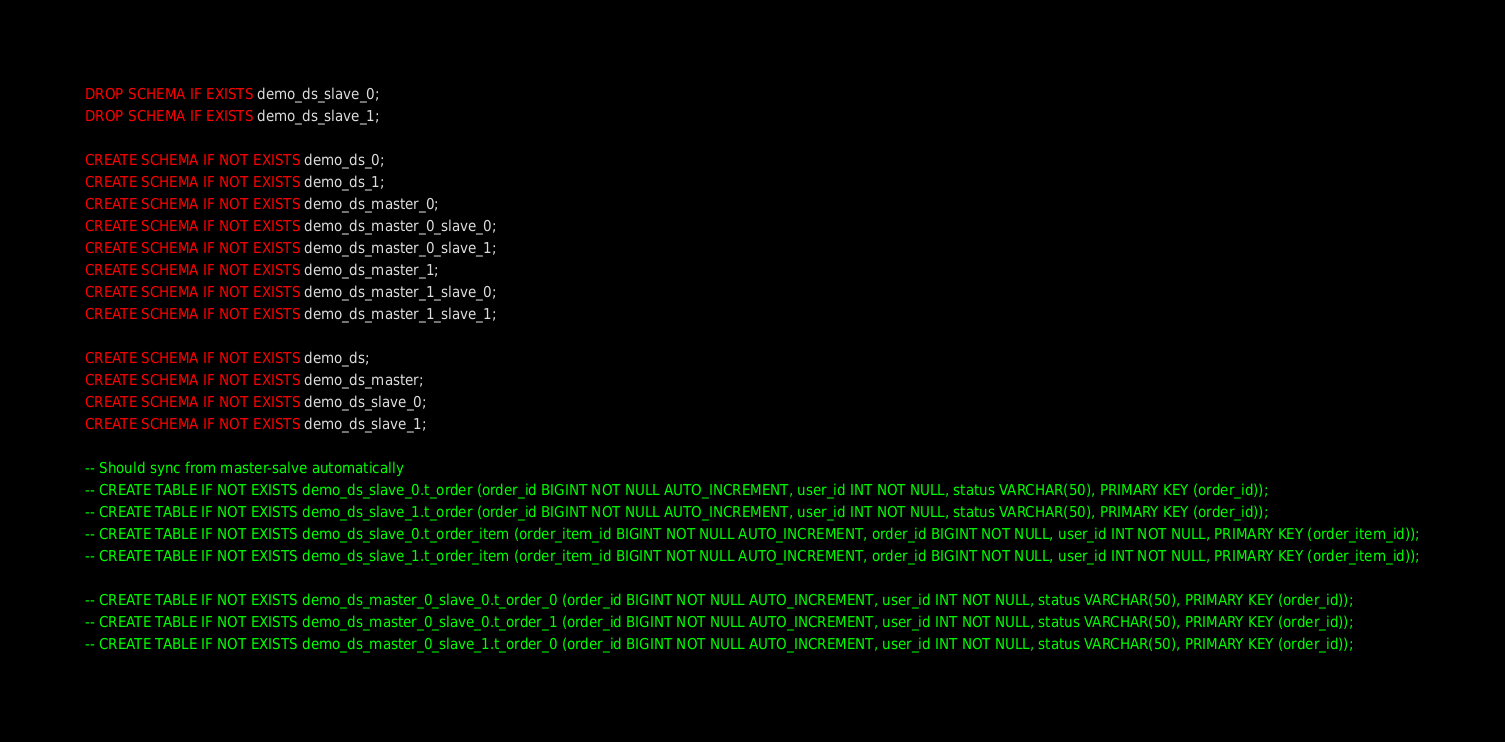Convert code to text. <code><loc_0><loc_0><loc_500><loc_500><_SQL_>DROP SCHEMA IF EXISTS demo_ds_slave_0;
DROP SCHEMA IF EXISTS demo_ds_slave_1;

CREATE SCHEMA IF NOT EXISTS demo_ds_0;
CREATE SCHEMA IF NOT EXISTS demo_ds_1;
CREATE SCHEMA IF NOT EXISTS demo_ds_master_0;
CREATE SCHEMA IF NOT EXISTS demo_ds_master_0_slave_0;
CREATE SCHEMA IF NOT EXISTS demo_ds_master_0_slave_1;
CREATE SCHEMA IF NOT EXISTS demo_ds_master_1;
CREATE SCHEMA IF NOT EXISTS demo_ds_master_1_slave_0;
CREATE SCHEMA IF NOT EXISTS demo_ds_master_1_slave_1;

CREATE SCHEMA IF NOT EXISTS demo_ds;
CREATE SCHEMA IF NOT EXISTS demo_ds_master;
CREATE SCHEMA IF NOT EXISTS demo_ds_slave_0;
CREATE SCHEMA IF NOT EXISTS demo_ds_slave_1;

-- Should sync from master-salve automatically
-- CREATE TABLE IF NOT EXISTS demo_ds_slave_0.t_order (order_id BIGINT NOT NULL AUTO_INCREMENT, user_id INT NOT NULL, status VARCHAR(50), PRIMARY KEY (order_id));
-- CREATE TABLE IF NOT EXISTS demo_ds_slave_1.t_order (order_id BIGINT NOT NULL AUTO_INCREMENT, user_id INT NOT NULL, status VARCHAR(50), PRIMARY KEY (order_id));
-- CREATE TABLE IF NOT EXISTS demo_ds_slave_0.t_order_item (order_item_id BIGINT NOT NULL AUTO_INCREMENT, order_id BIGINT NOT NULL, user_id INT NOT NULL, PRIMARY KEY (order_item_id));
-- CREATE TABLE IF NOT EXISTS demo_ds_slave_1.t_order_item (order_item_id BIGINT NOT NULL AUTO_INCREMENT, order_id BIGINT NOT NULL, user_id INT NOT NULL, PRIMARY KEY (order_item_id));

-- CREATE TABLE IF NOT EXISTS demo_ds_master_0_slave_0.t_order_0 (order_id BIGINT NOT NULL AUTO_INCREMENT, user_id INT NOT NULL, status VARCHAR(50), PRIMARY KEY (order_id));
-- CREATE TABLE IF NOT EXISTS demo_ds_master_0_slave_0.t_order_1 (order_id BIGINT NOT NULL AUTO_INCREMENT, user_id INT NOT NULL, status VARCHAR(50), PRIMARY KEY (order_id));
-- CREATE TABLE IF NOT EXISTS demo_ds_master_0_slave_1.t_order_0 (order_id BIGINT NOT NULL AUTO_INCREMENT, user_id INT NOT NULL, status VARCHAR(50), PRIMARY KEY (order_id));</code> 